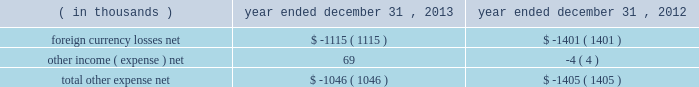Other expense , net : the company's other expense consists of the following: .
Income tax provision : the company recorded income tax expense of $ 77.2 million and had income before income taxes of $ 322.5 million for the year ended december 31 , 2013 , representing an effective tax rate of 23.9% ( 23.9 % ) .
During the year ended december 31 , 2012 , the company recorded income tax expense of $ 90.1 million and had income before income taxes of $ 293.5 million , representing an effective tax rate of 30.7% ( 30.7 % ) .
In december 2013 , the company received notice from the irs that the joint committee on taxation took no exception to the company's tax returns that were filed for 2009 and 2010 .
An $ 11.0 million tax benefit was recognized in the company's 2013 financial results as the company had effectively settled uncertainty regarding the realization of refund claims filed in connection with the 2009 and 2010 returns .
In the u.s. , which is the largest jurisdiction where the company receives such a tax credit , the availability of the research and development credit expired at the end of the 2011 tax year .
In january 2013 , the u.s .
Congress passed legislation that reinstated the research and development credit retroactive to 2012 .
The income tax provision for the year ended december 31 , 2013 includes approximately $ 2.3 million related to the reinstated research and development credit for 2012 activity .
The decrease in the effective tax rate from the prior year is primarily due to the release of an uncertain tax position mentioned above , the reinstatement of the u.s .
Research and development credit mentioned above , and cash repatriation activities .
When compared to the federal and state combined statutory rate , the effective tax rates for the years ended december 31 , 2013 and 2012 were favorably impacted by lower statutory tax rates in many of the company 2019s foreign jurisdictions , the domestic manufacturing deduction and tax benefits associated with the merger of the company 2019s japan subsidiaries in 2010 .
Net income : the company 2019s net income for the year ended december 31 , 2013 was $ 245.3 million as compared to net income of $ 203.5 million for the year ended december 31 , 2012 .
Diluted earnings per share was $ 2.58 for the year ended december 31 , 2013 and $ 2.14 for the year ended december 31 , 2012 .
The weighted average shares used in computing diluted earnings per share were 95.1 million and 95.0 million for the years ended december 31 , 2013 and 2012 , respectively .
Table of contents .
What was the percentage change in the company 2019s net income from 2012 to 2013 .? 
Computations: ((245.3 - 203.5) / 203.5)
Answer: 0.20541. 